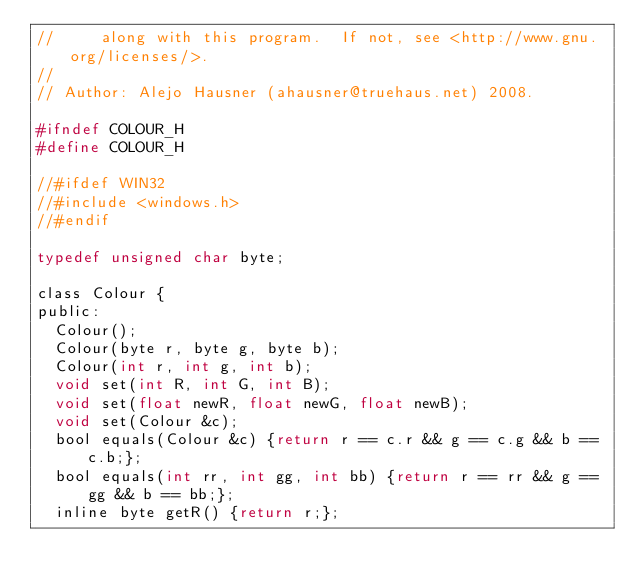<code> <loc_0><loc_0><loc_500><loc_500><_C_>//     along with this program.  If not, see <http://www.gnu.org/licenses/>.
//
// Author: Alejo Hausner (ahausner@truehaus.net) 2008.

#ifndef COLOUR_H
#define COLOUR_H

//#ifdef WIN32
//#include <windows.h>
//#endif

typedef unsigned char byte;

class Colour {
public:
  Colour();
  Colour(byte r, byte g, byte b);
  Colour(int r, int g, int b);
  void set(int R, int G, int B);
  void set(float newR, float newG, float newB);
  void set(Colour &c);
  bool equals(Colour &c) {return r == c.r && g == c.g && b == c.b;};
  bool equals(int rr, int gg, int bb) {return r == rr && g == gg && b == bb;};
  inline byte getR() {return r;};</code> 